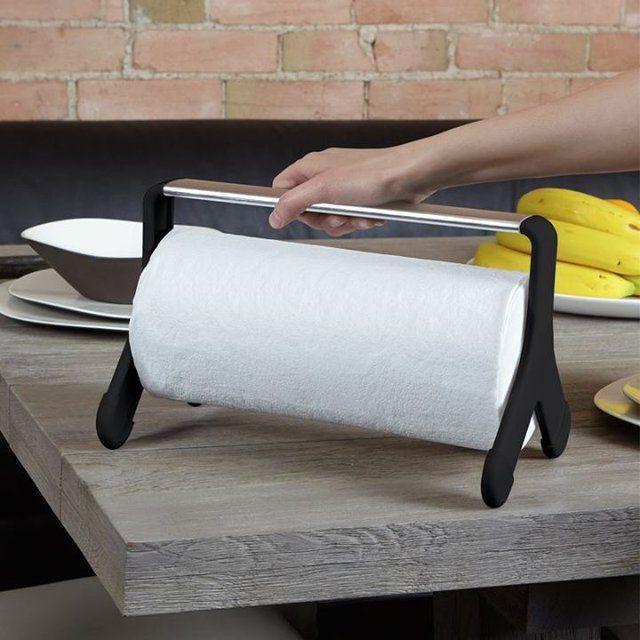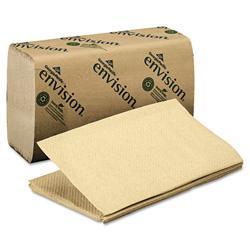The first image is the image on the left, the second image is the image on the right. Considering the images on both sides, is "One of the images shows brown folded paper towels." valid? Answer yes or no. Yes. The first image is the image on the left, the second image is the image on the right. For the images displayed, is the sentence "Each roll of paper towel is on a roller." factually correct? Answer yes or no. No. 